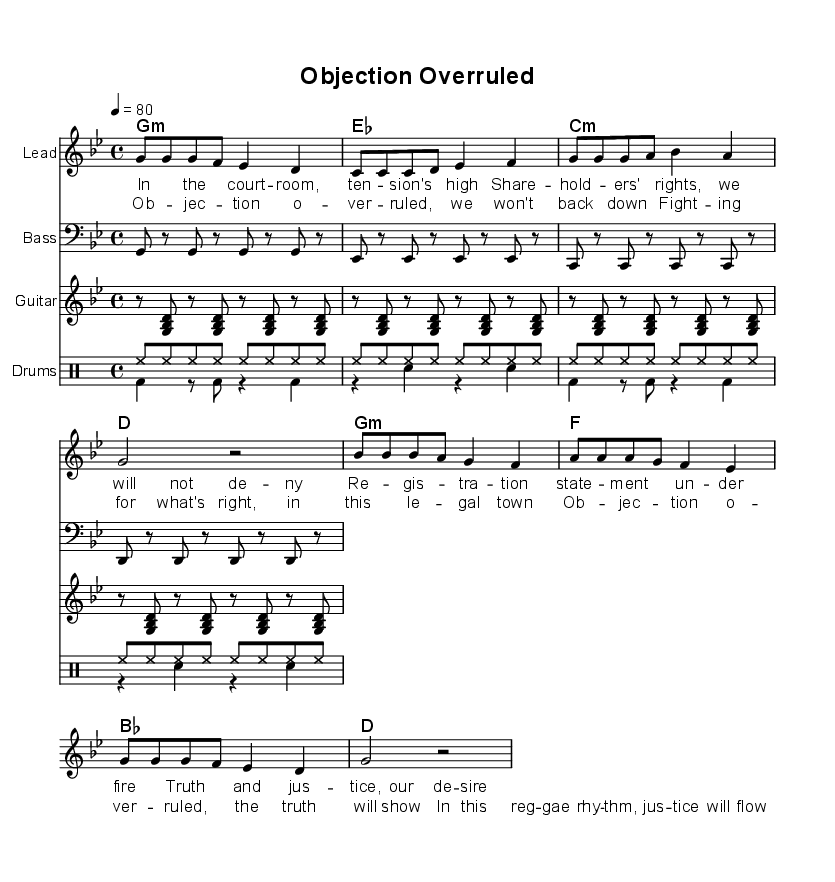What is the key signature of this music? The key signature is indicated by the number of sharps or flats at the beginning of the piece. In this case, there are no sharps or flats, indicating that it is in G minor.
Answer: G minor What is the time signature of this piece? The time signature is noted at the beginning of the staff, showing how many beats are in each measure. Here, it is written as 4/4, meaning there are 4 beats per measure.
Answer: 4/4 What is the tempo marking of this music? The tempo marking, which indicates how fast to play the piece, is shown at the beginning with a number. In this case, it states 4=80, suggesting a speed of 80 beats per minute.
Answer: 80 What are the primary chord changes during the verse? To determine the chord changes, we look at the chord names given in the chord section. The chords listed for the verse are G minor, E flat, C minor, and D.
Answer: G minor, E flat, C minor, D What is the central theme of the lyrics? The lyrics express a theme related to legal battles and struggles for justice and truth, aligning with the reggae style of addressing social issues. The lyrics mention fighting for rights and justice in a courtroom setting.
Answer: Legal battles and justice Which instrument is designated as the lead? The lead part is indicated in the score under "Lead," where the melody is written. It is separate from other instruments like the bass and guitar, further identifying its role.
Answer: Lead 